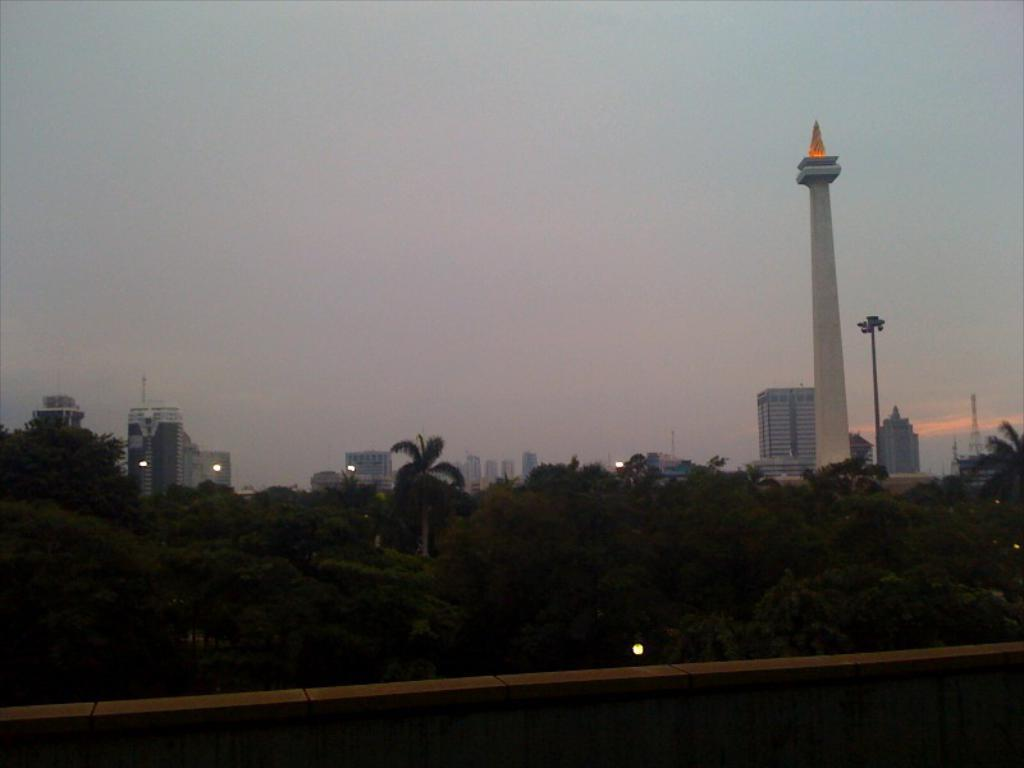What type of natural elements can be seen in the image? There are trees in the image. What type of man-made structures are present in the image? There are buildings in the image. What is the value of the pie in the image? There is no pie present in the image, so it is not possible to determine its value. 